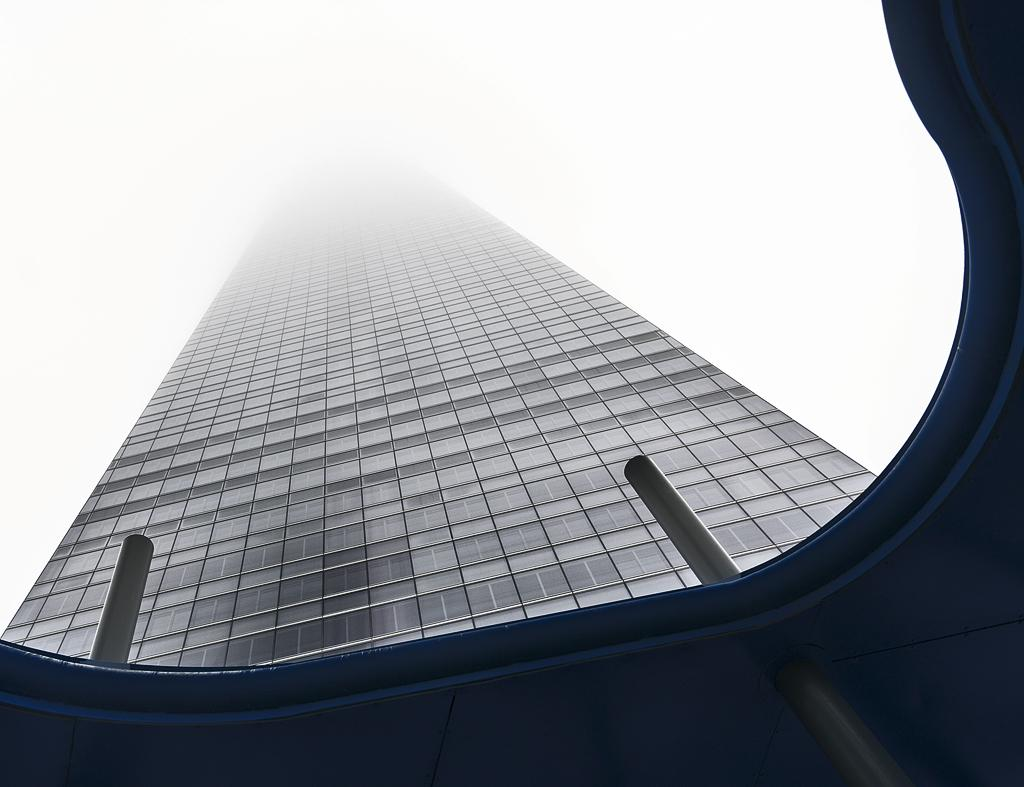What structures can be seen in the image? There are two poles and a building in the image. Can you describe the building in the image? The building is grey in color. What is visible in the background of the image? The sky is visible in the background of the image. Can you see a tiger walking between the two poles in the image? No, there is no tiger present in the image. Is there a plane flying over the building in the image? No, there is no plane visible in the image. 